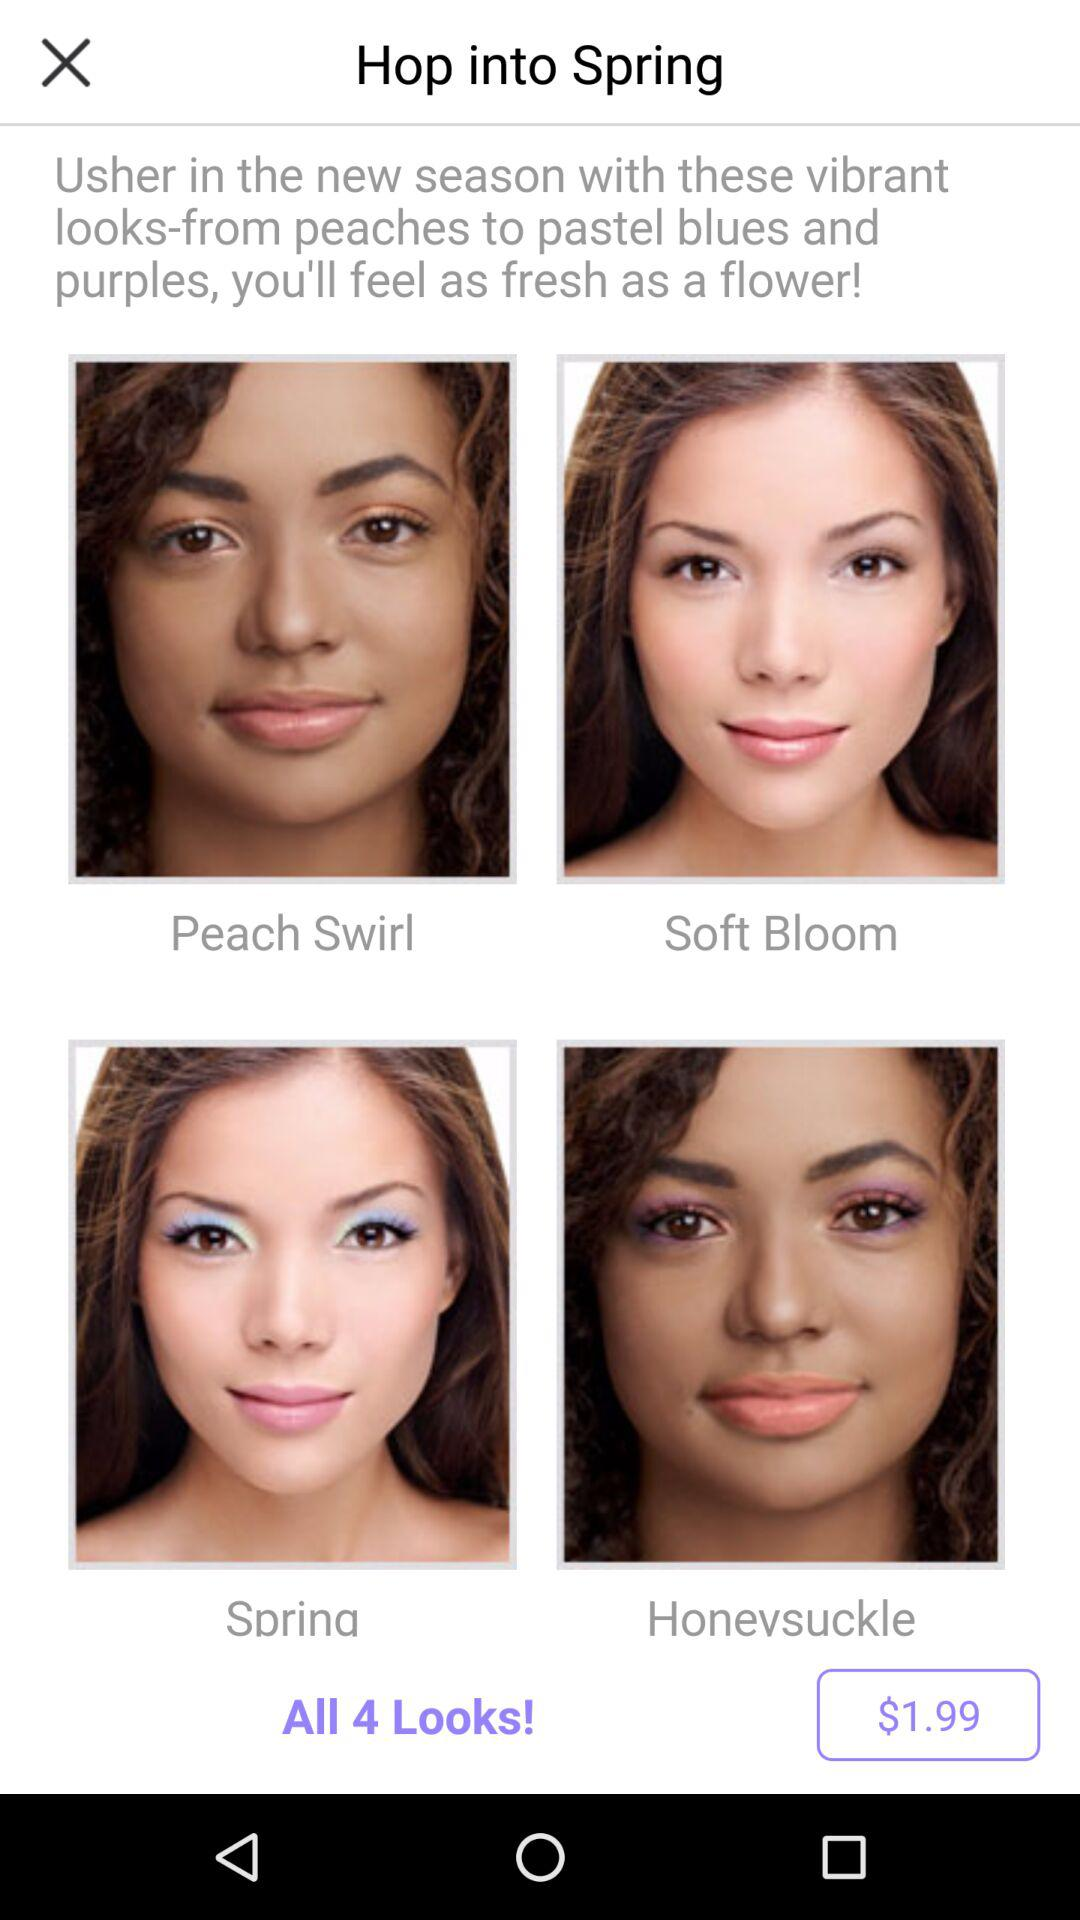Which version of the application is this?
When the provided information is insufficient, respond with <no answer>. <no answer> 